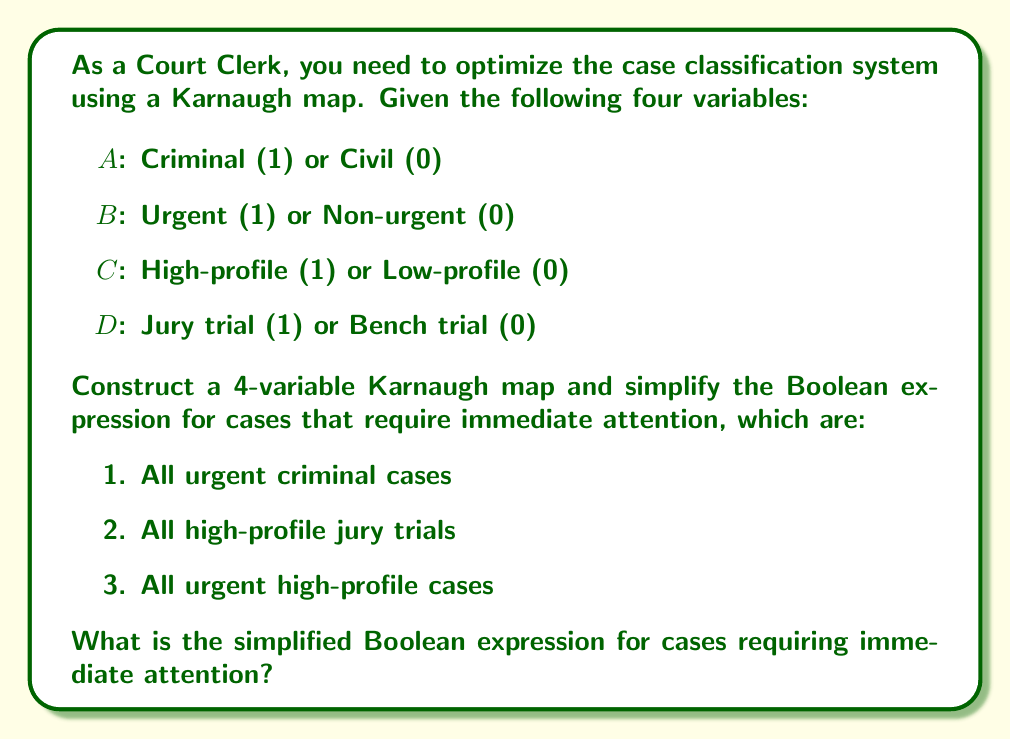Could you help me with this problem? Let's approach this step-by-step:

1. First, we need to create a truth table for the given conditions:

   $F = A \cdot B + C \cdot D + B \cdot C$

2. Now, we can construct a 4-variable Karnaugh map:

   [asy]
   unitsize(1cm);
   for(int i=0; i<4; ++i)
     for(int j=0; j<4; ++j)
       draw((i,j)--(i+1,j)--(i+1,j+1)--(i,j+1)--cycle);
   label("AB\CD", (-0.5,4.5));
   label("00", (0.5,4.5)); label("01", (1.5,4.5)); label("11", (2.5,4.5)); label("10", (3.5,4.5));
   label("00", (-0.5,3.5)); label("01", (-0.5,2.5)); label("11", (-0.5,1.5)); label("10", (-0.5,0.5));
   label("1", (0.5,3.5)); label("1", (1.5,3.5)); label("1", (2.5,3.5)); label("1", (3.5,3.5));
   label("0", (0.5,2.5)); label("1", (1.5,2.5)); label("1", (2.5,2.5)); label("1", (3.5,2.5));
   label("1", (0.5,1.5)); label("1", (1.5,1.5)); label("1", (2.5,1.5)); label("1", (3.5,1.5));
   label("1", (0.5,0.5)); label("1", (1.5,0.5)); label("1", (2.5,0.5)); label("1", (3.5,0.5));
   [/asy]

3. We can identify three groups in this Karnaugh map:
   - A vertical rectangle for $A \cdot B$ (urgent criminal cases)
   - A horizontal rectangle for $C \cdot D$ (high-profile jury trials)
   - A large square for $B \cdot C$ (urgent high-profile cases)

4. The simplified Boolean expression is the OR of these three terms:

   $F = A \cdot B + C \cdot D + B \cdot C$

This expression cannot be simplified further using the Karnaugh map method.
Answer: $F = A \cdot B + C \cdot D + B \cdot C$ 